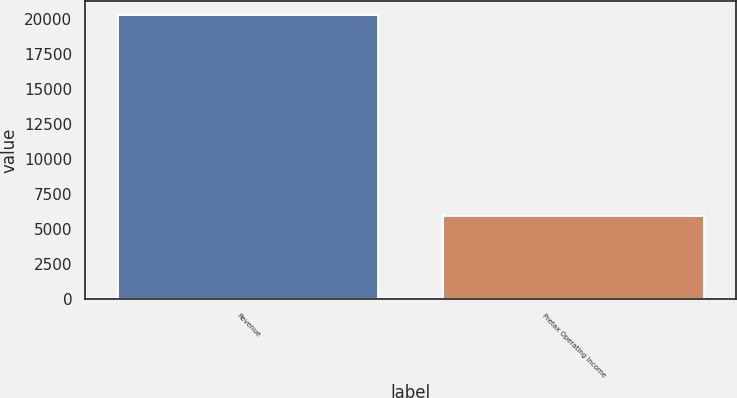<chart> <loc_0><loc_0><loc_500><loc_500><bar_chart><fcel>Revenue<fcel>Pretax Operating Income<nl><fcel>20306<fcel>5959<nl></chart> 